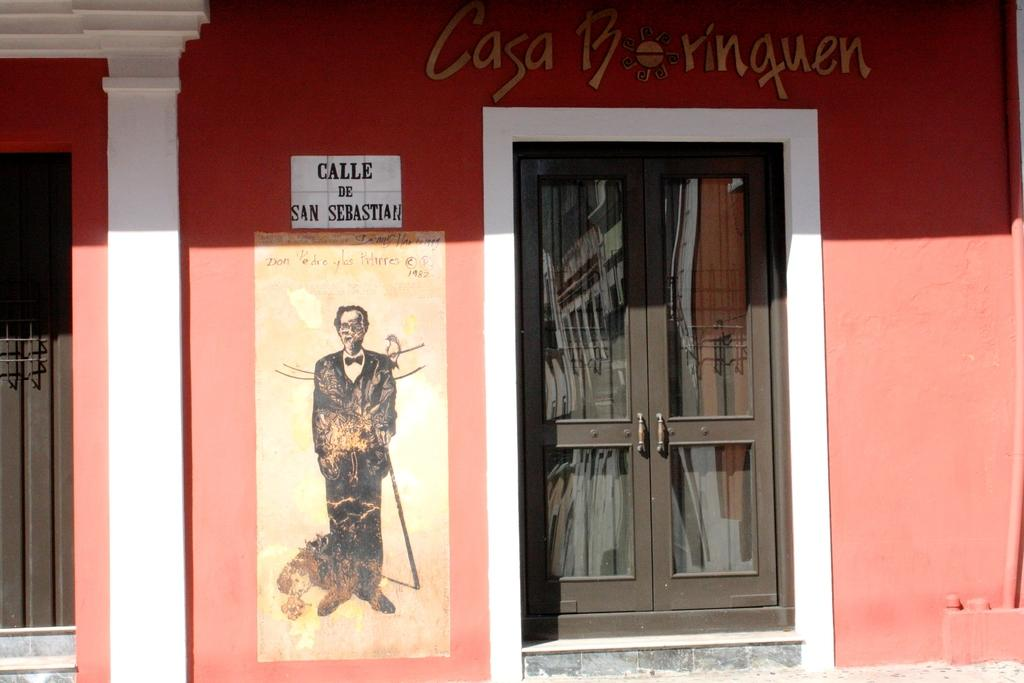What is hanging on the wall in the image? There is a poster and a painting on the wall in the image. What else can be seen on the wall in the image? There is text on the wall at the top of the image. Are there any architectural features near the poster in the image? Yes, there are doors beside the poster in the image. How many goldfish are swimming in the painting in the image? There is no painting of goldfish in the image; the painting's subject is not mentioned in the provided facts. 